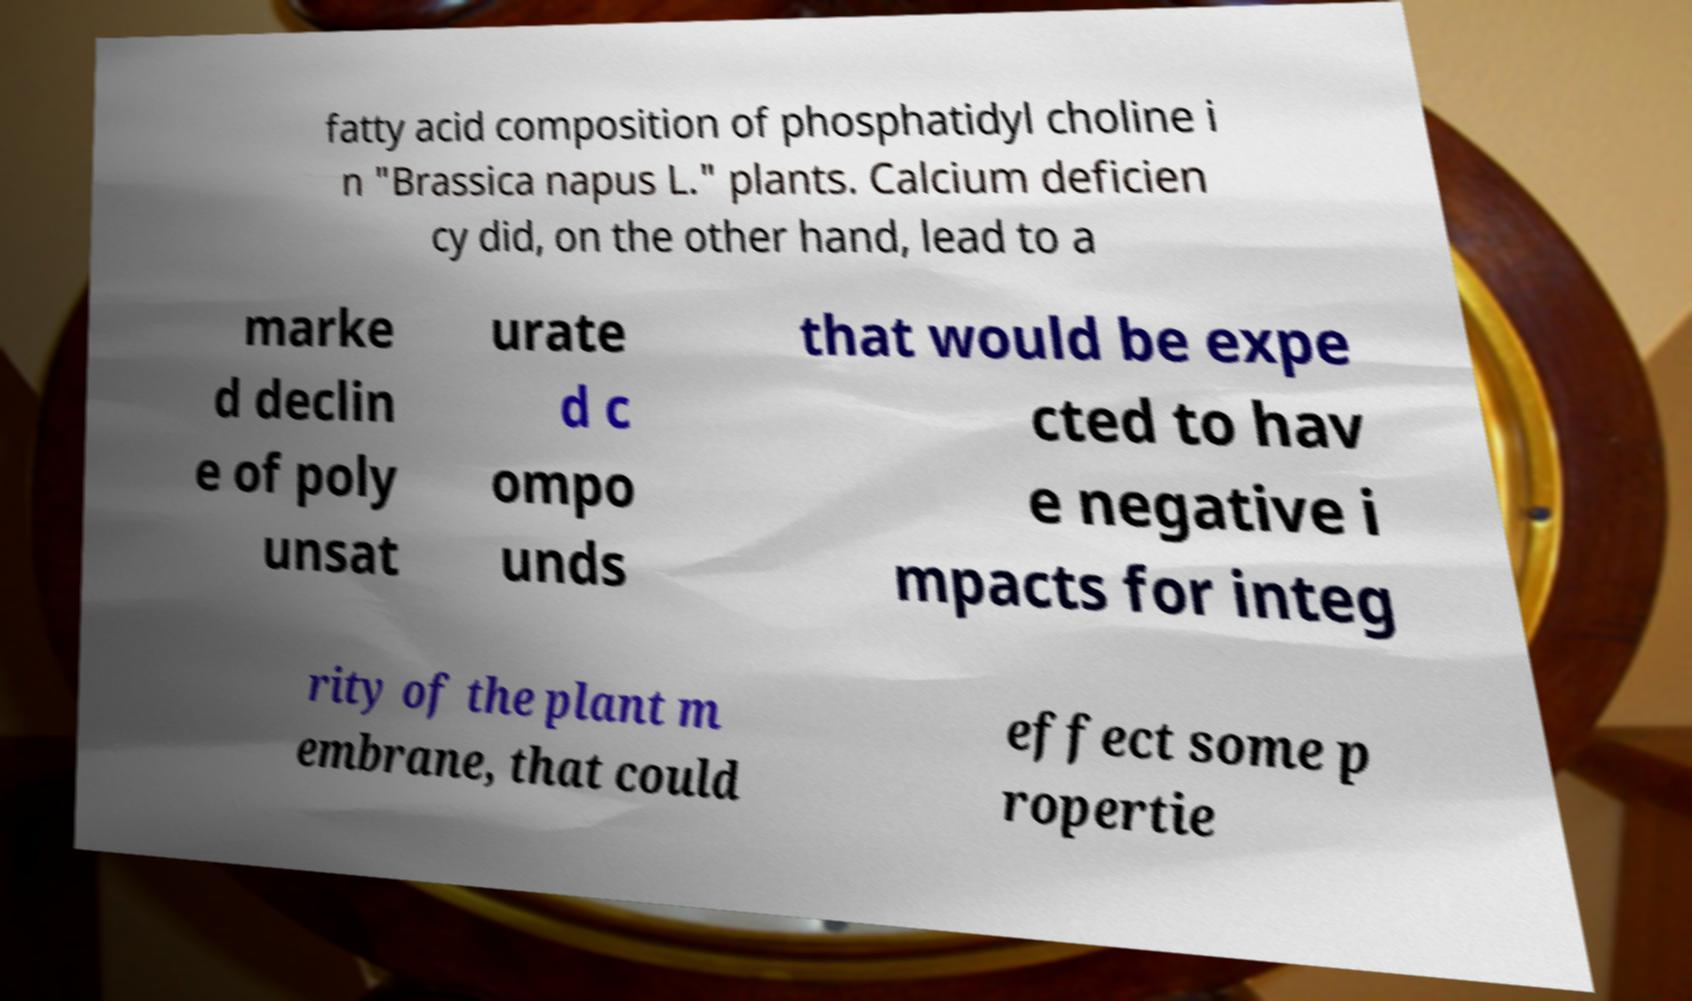What messages or text are displayed in this image? I need them in a readable, typed format. fatty acid composition of phosphatidyl choline i n "Brassica napus L." plants. Calcium deficien cy did, on the other hand, lead to a marke d declin e of poly unsat urate d c ompo unds that would be expe cted to hav e negative i mpacts for integ rity of the plant m embrane, that could effect some p ropertie 